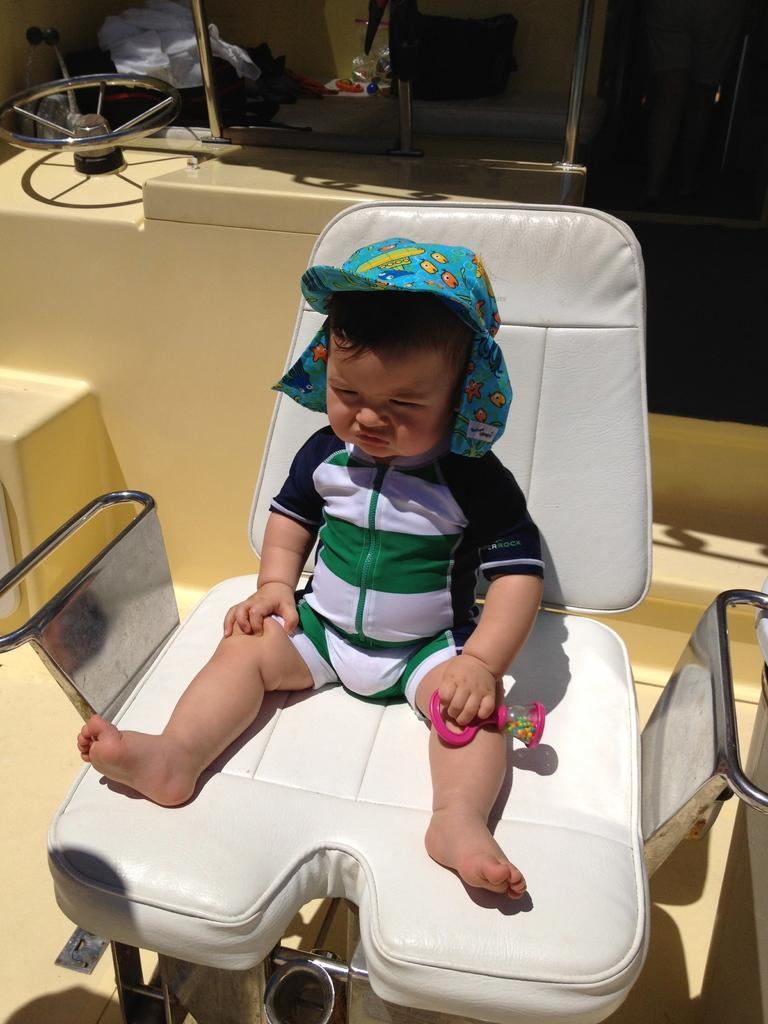What type of setting is depicted in the image? The image appears to depict a clinic setting. What type of chair is present in the image? There is a white color chair in the image. Who is sitting on the chair? A kid is sitting on the chair. What can be seen in the background of the image? There is equipment visible in the background of the image. What type of pies are being served in the image? There are no pies present in the image; it depicts a clinic setting with a kid sitting on a white chair. How many steps are visible in the image? There are no steps visible in the image; it shows a clinic setting with a kid sitting on a white chair and equipment in the background. 